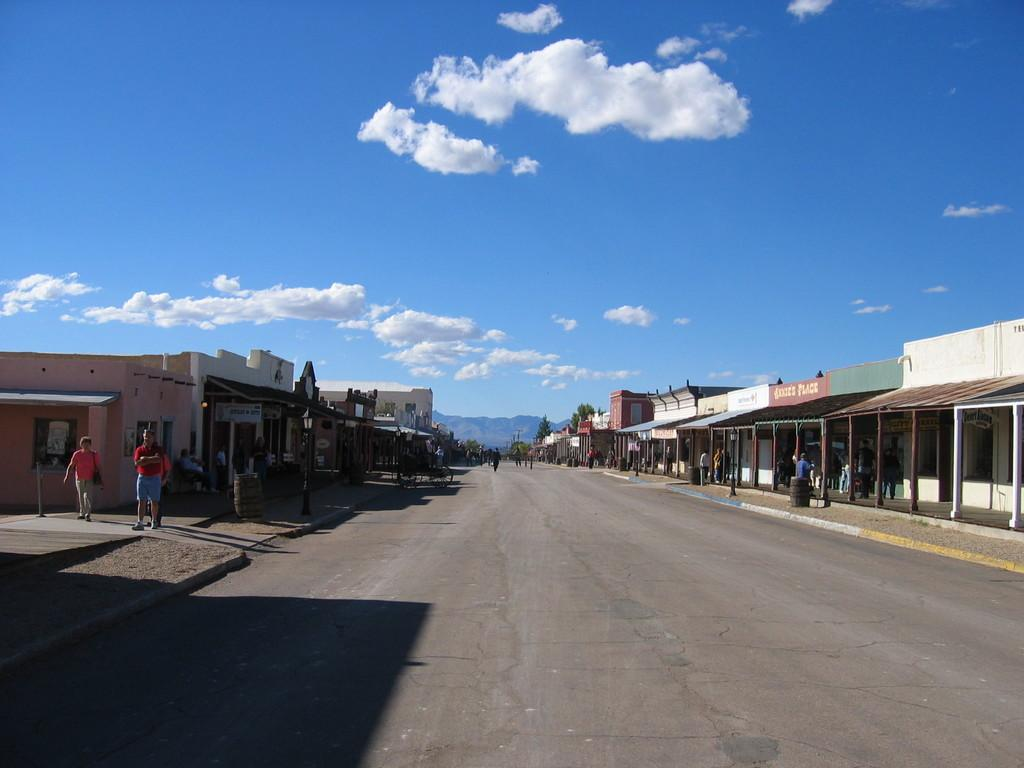What type of structures can be seen in the image? There are buildings in the image. What natural elements are present in the image? There are trees in the image. What are the people in the image doing? There are people walking in the image. What geographical feature is visible in the image? There is a hill in the image. How would you describe the weather based on the sky in the image? The sky is blue and cloudy in the image. Can you tell me how many gloves are being worn by the people in the image? There are no gloves visible in the image; the people are walking without gloves. What type of nerve can be seen in the image? There are no nerves present in the image; it features buildings, trees, people walking, a hill, and a blue and cloudy sky. 